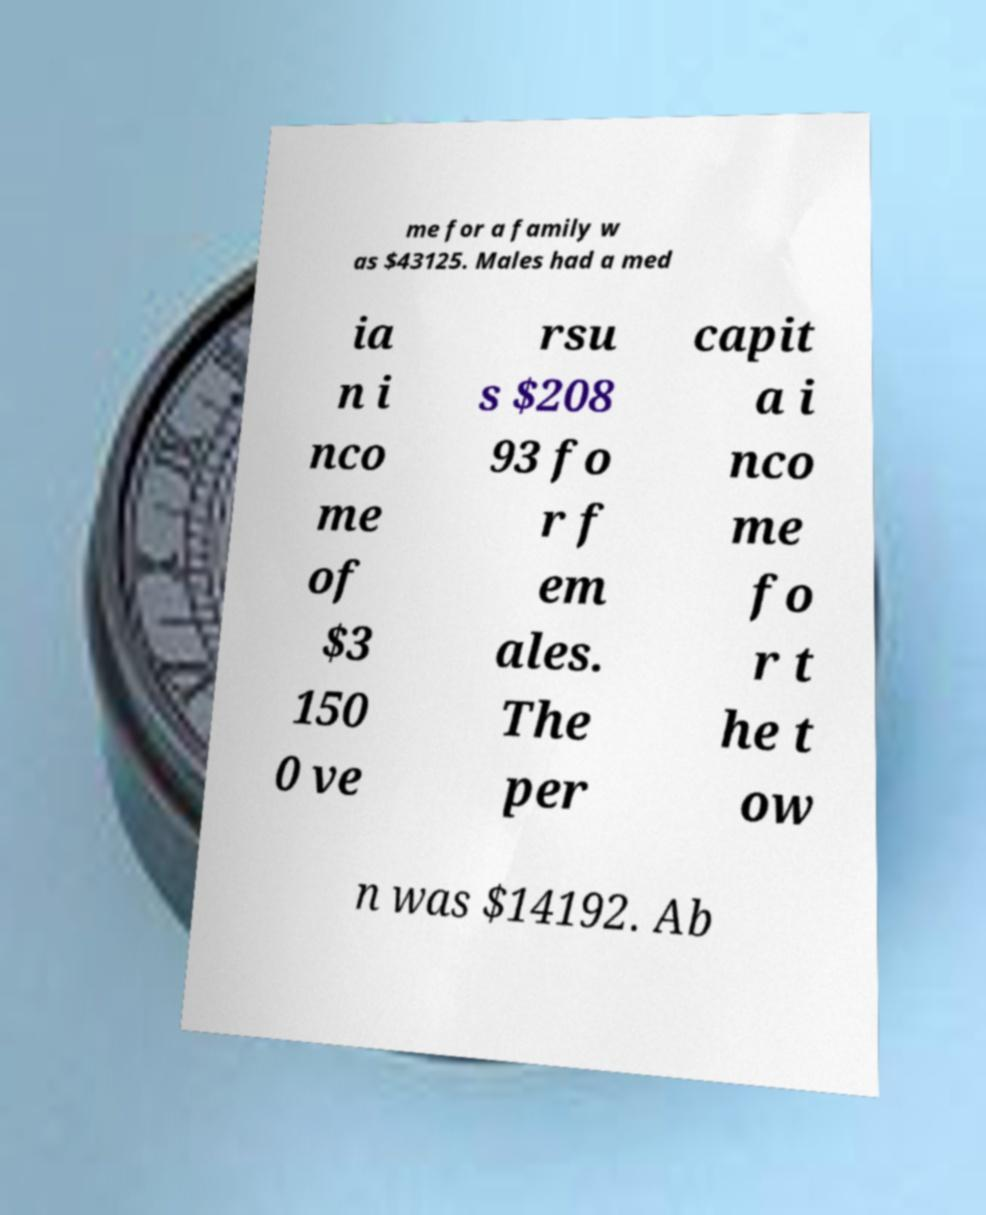What messages or text are displayed in this image? I need them in a readable, typed format. me for a family w as $43125. Males had a med ia n i nco me of $3 150 0 ve rsu s $208 93 fo r f em ales. The per capit a i nco me fo r t he t ow n was $14192. Ab 